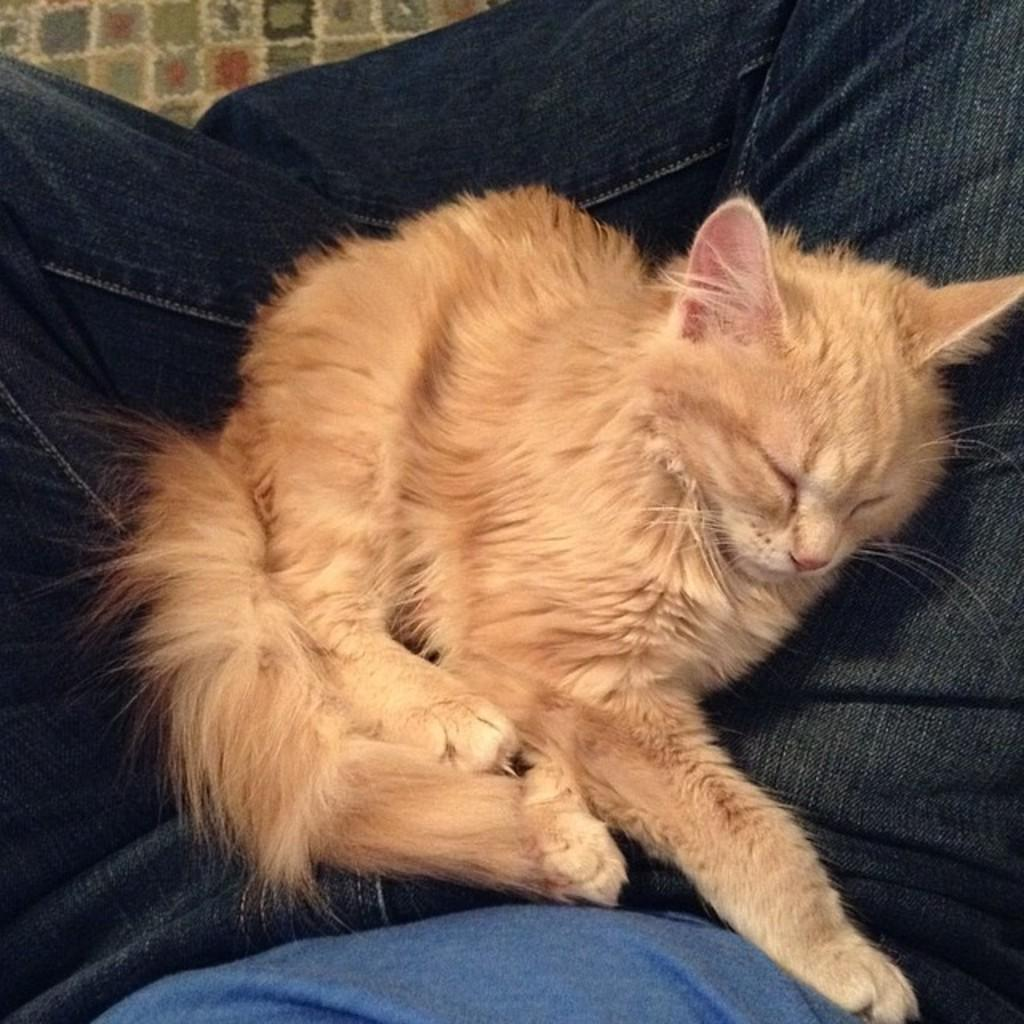What animal can be seen in the image? There is a cat in the image. What is the cat doing in the image? The cat is sleeping. Where is the cat located in the image? The cat is on a person's lap. What type of clothing is the person wearing on their upper body? The person is wearing a T-shirt. What type of clothing is the person wearing on their lower body? The person is wearing trousers. What type of juice is the cat drinking in the image? There is no juice present in the image; the cat is sleeping on the person's lap. 